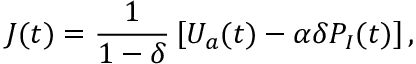<formula> <loc_0><loc_0><loc_500><loc_500>J ( t ) = \frac { 1 } { 1 - \delta } \left [ U _ { a } ( t ) - \alpha \delta P _ { I } ( t ) \right ] ,</formula> 